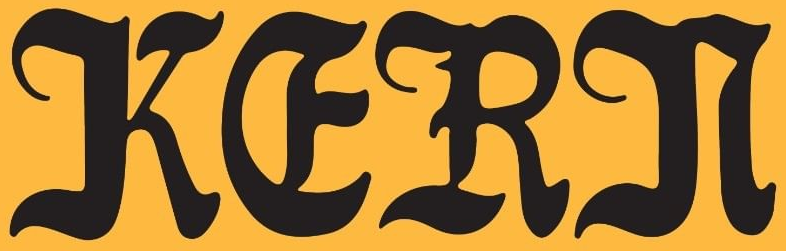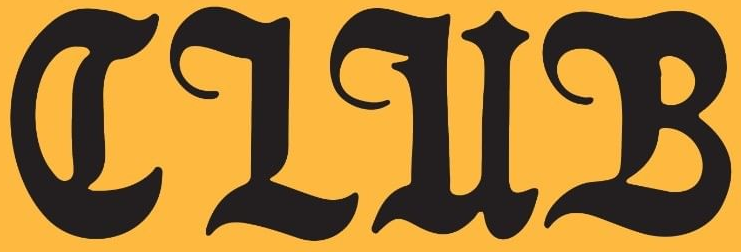What words are shown in these images in order, separated by a semicolon? KERN; CLUB 